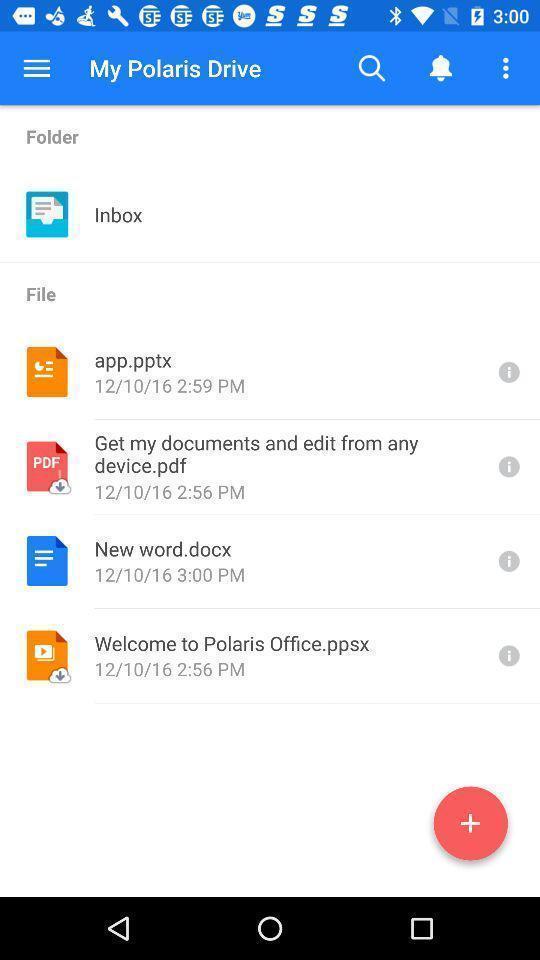Summarize the main components in this picture. Screen shows list of my polaris drive. 